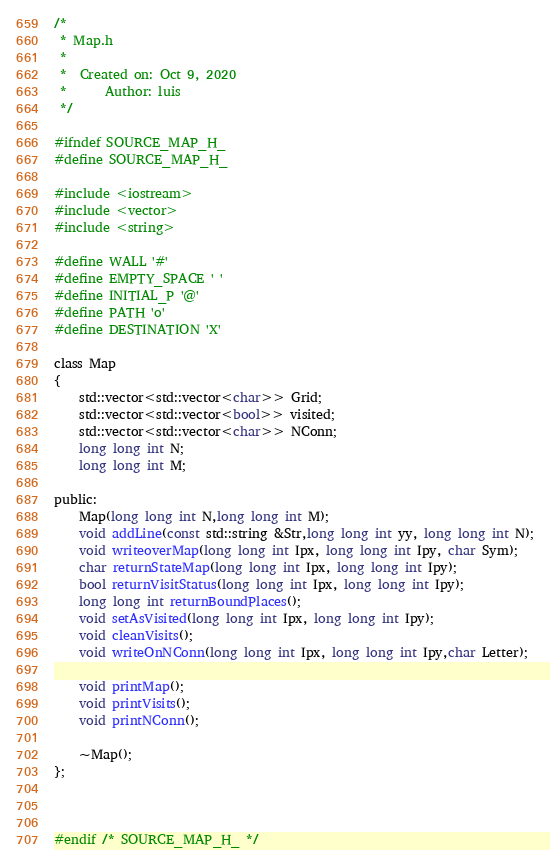Convert code to text. <code><loc_0><loc_0><loc_500><loc_500><_C_>/*
 * Map.h
 *
 *  Created on: Oct 9, 2020
 *      Author: luis
 */

#ifndef SOURCE_MAP_H_
#define SOURCE_MAP_H_

#include <iostream>
#include <vector>
#include <string>

#define WALL '#'
#define EMPTY_SPACE ' '
#define INITIAL_P '@'
#define PATH 'o'
#define DESTINATION 'X'

class Map
{
	std::vector<std::vector<char>> Grid;
	std::vector<std::vector<bool>> visited;
	std::vector<std::vector<char>> NConn;
	long long int N;
	long long int M;

public:
	Map(long long int N,long long int M);
	void addLine(const std::string &Str,long long int yy, long long int N);
	void writeoverMap(long long int Ipx, long long int Ipy, char Sym);
	char returnStateMap(long long int Ipx, long long int Ipy);
	bool returnVisitStatus(long long int Ipx, long long int Ipy);
	long long int returnBoundPlaces();
	void setAsVisited(long long int Ipx, long long int Ipy);
	void cleanVisits();
	void writeOnNConn(long long int Ipx, long long int Ipy,char Letter);

	void printMap();
	void printVisits();
	void printNConn();

	~Map();
};



#endif /* SOURCE_MAP_H_ */
</code> 